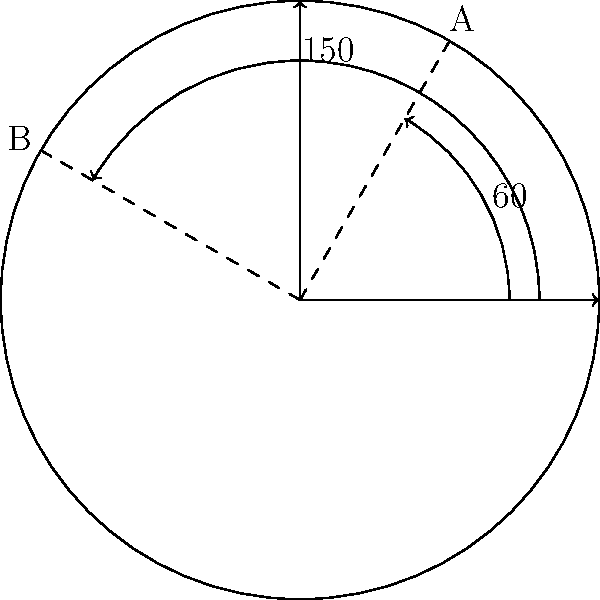In a circular wine cellar, bottles are arranged in a spiral pattern. Two rare vintage bottles, A and B, are placed along this spiral. If bottle A is at a 60° angle from the entrance and bottle B is at a 150° angle, what is the smallest positive angle between these two bottles? To find the smallest positive angle between the two bottles, we need to:

1. Identify the given angles:
   - Bottle A is at 60° from the entrance
   - Bottle B is at 150° from the entrance

2. Calculate the difference between these angles:
   $150° - 60° = 90°$

3. Consider that the smallest positive angle could be either this difference or its complement to 360°:
   $360° - 90° = 270°$

4. Compare the two possible angles:
   90° is smaller than 270°

5. Therefore, the smallest positive angle between the two bottles is 90°.

This angle represents the shortest arc length along the circular arrangement between bottles A and B.
Answer: 90° 